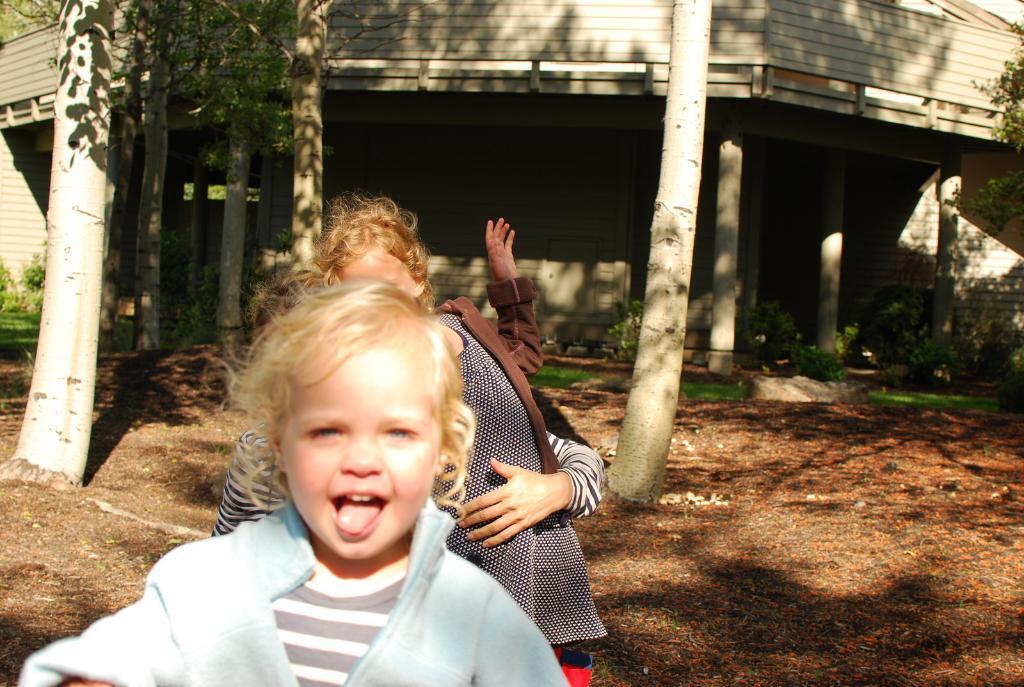Could you give a brief overview of what you see in this image? In this image we can see girls standing on the ground. In the background we can see trees and building. 